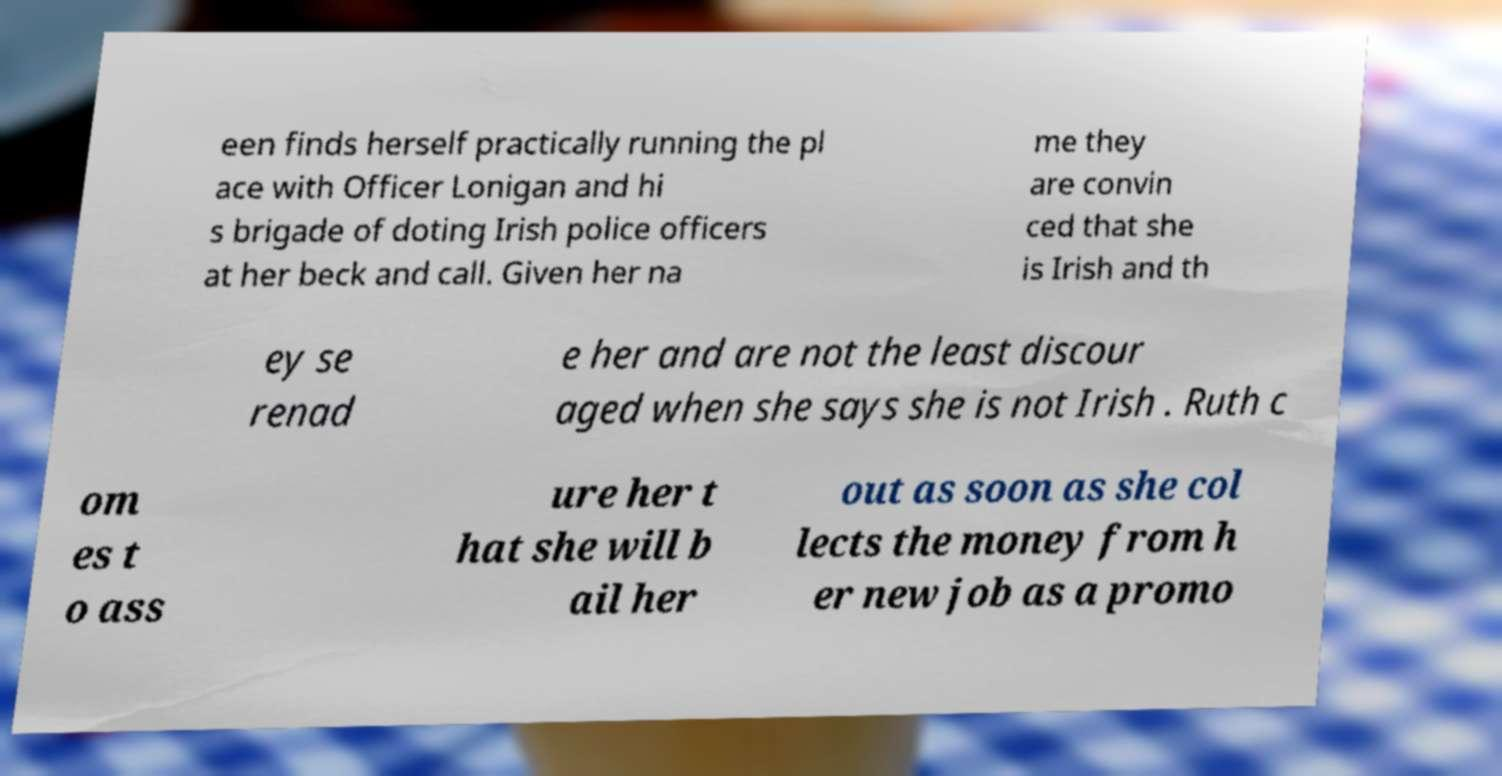Please read and relay the text visible in this image. What does it say? een finds herself practically running the pl ace with Officer Lonigan and hi s brigade of doting Irish police officers at her beck and call. Given her na me they are convin ced that she is Irish and th ey se renad e her and are not the least discour aged when she says she is not Irish . Ruth c om es t o ass ure her t hat she will b ail her out as soon as she col lects the money from h er new job as a promo 